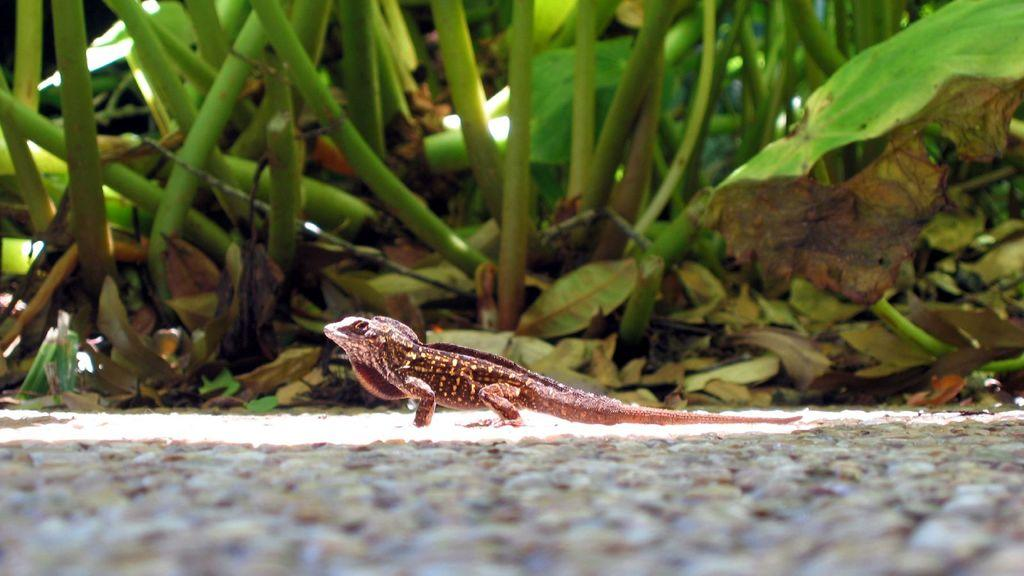What is at the bottom of the image? There is pavement at the bottom of the image. What type of animal can be seen in the middle of the image? There is a reptile in the middle of the image, which resembles a chameleon. What can be seen in the background of the image? Dry leaves, twigs, and plants or trees are visible in the background of the image. What type of sack is being carried by the representative in the image? There is no representative or sack present in the image. What school is depicted in the image? There is no school depicted in the image. 